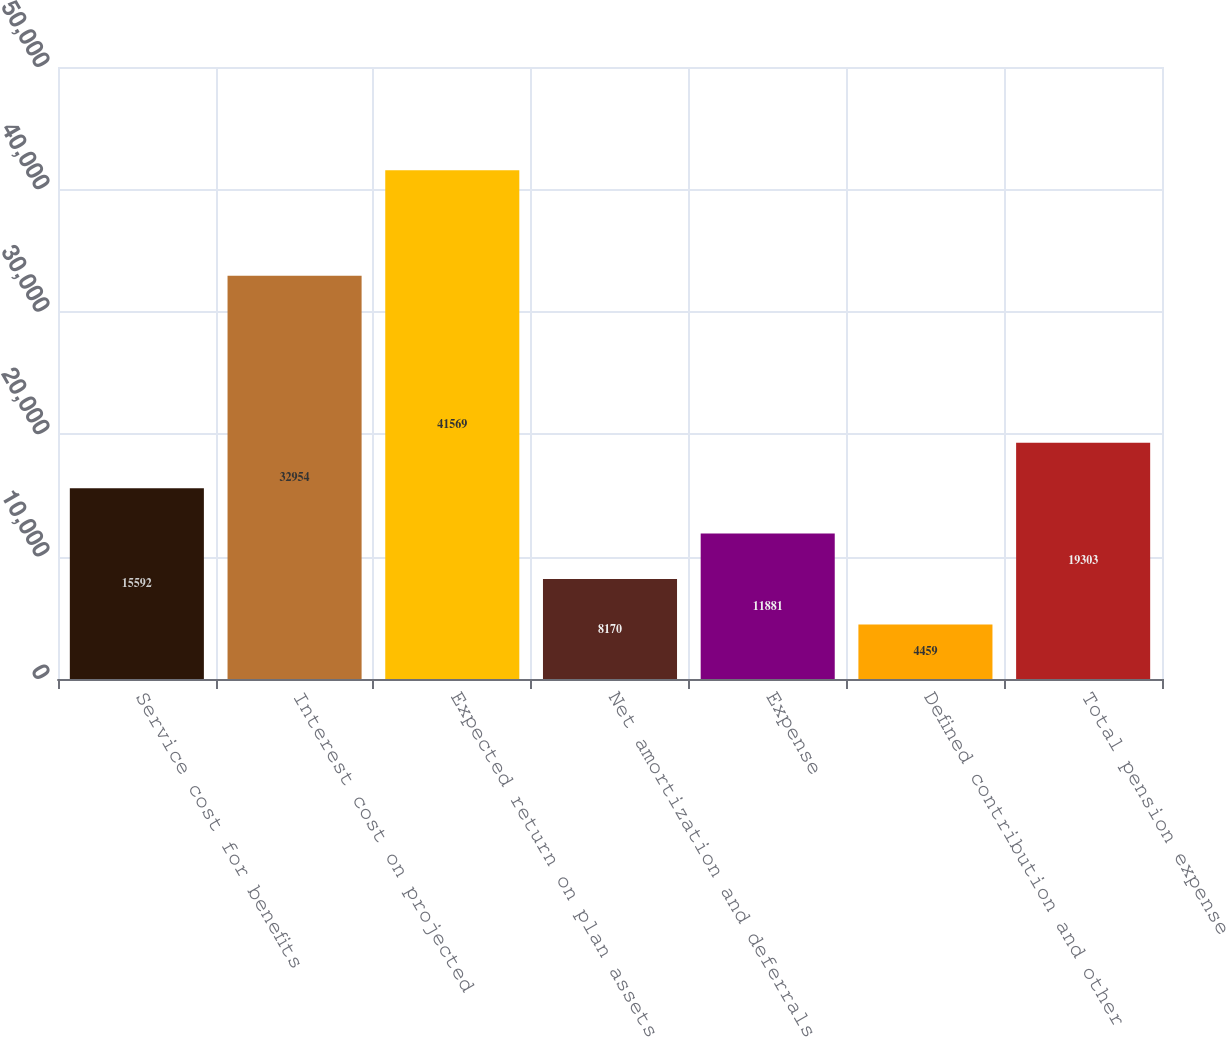Convert chart. <chart><loc_0><loc_0><loc_500><loc_500><bar_chart><fcel>Service cost for benefits<fcel>Interest cost on projected<fcel>Expected return on plan assets<fcel>Net amortization and deferrals<fcel>Expense<fcel>Defined contribution and other<fcel>Total pension expense<nl><fcel>15592<fcel>32954<fcel>41569<fcel>8170<fcel>11881<fcel>4459<fcel>19303<nl></chart> 